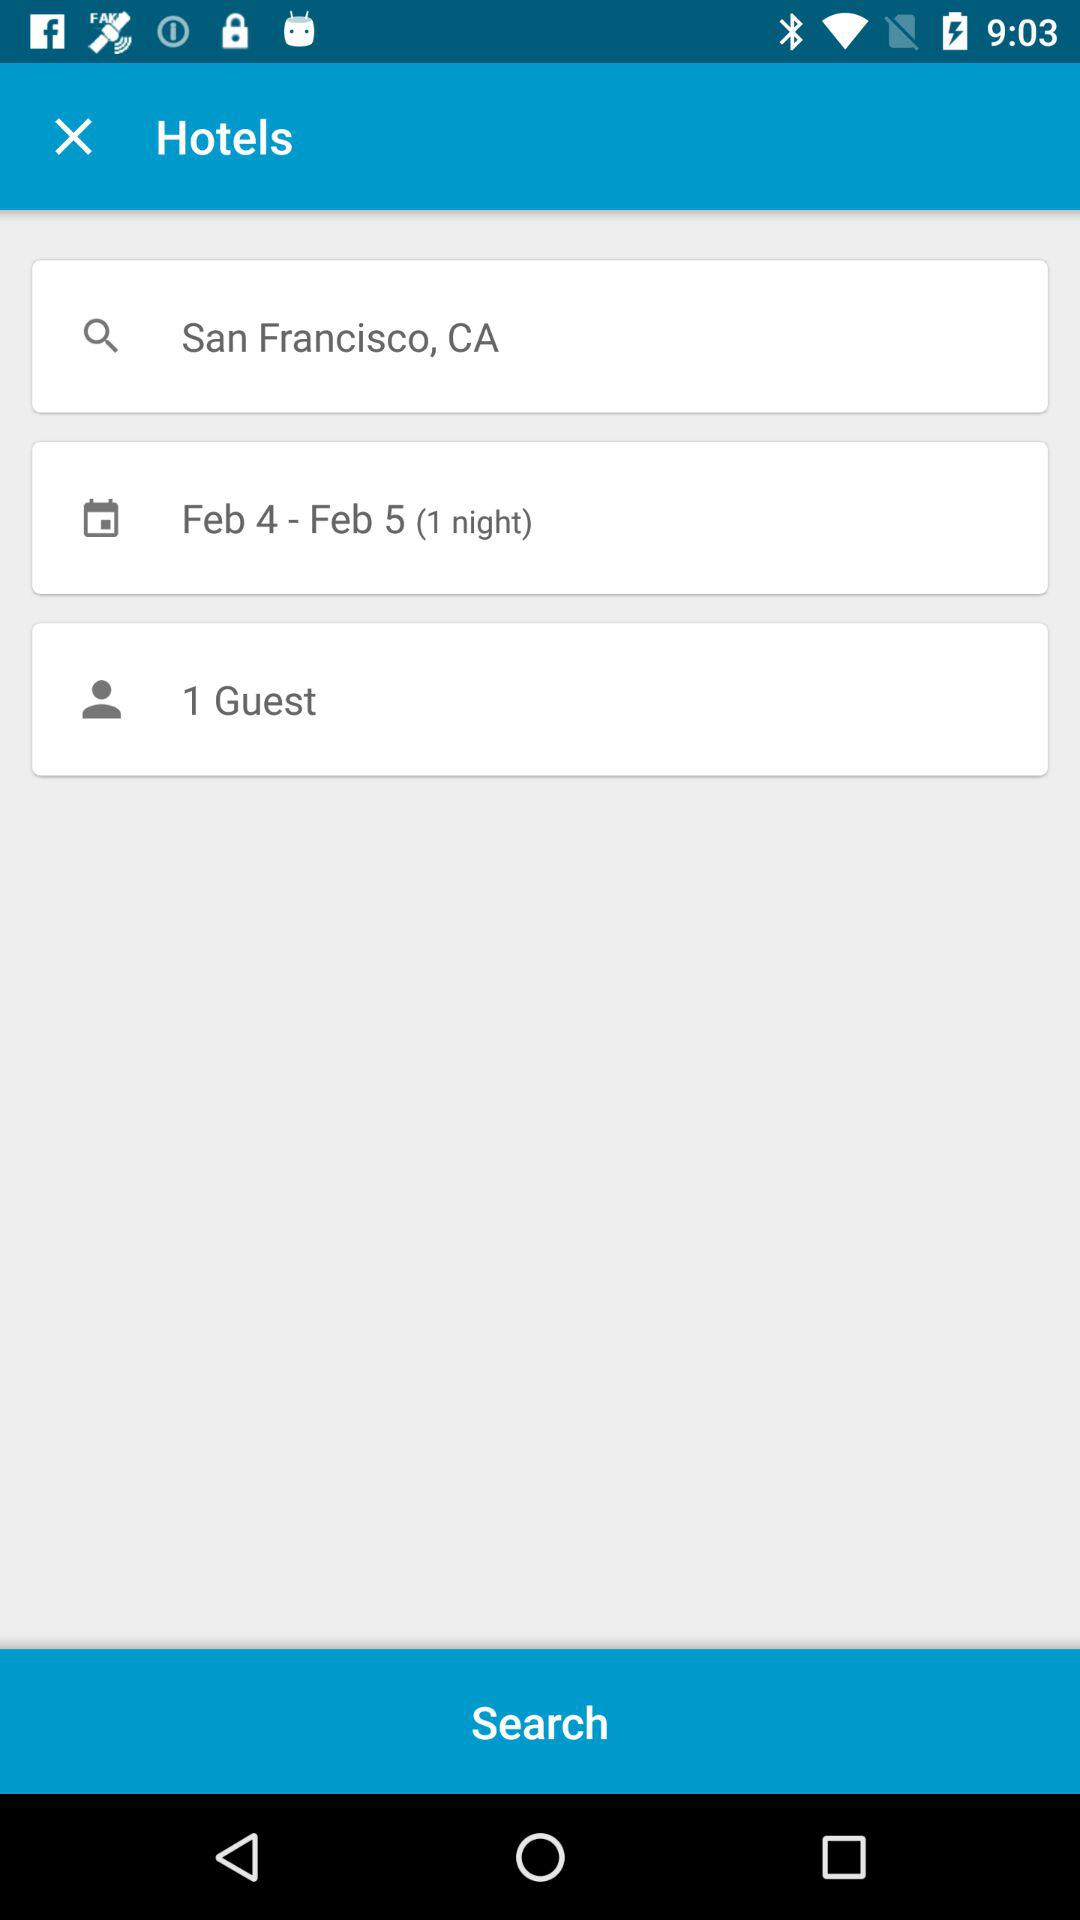How many days have been selected for this search?
Answer the question using a single word or phrase. 1 